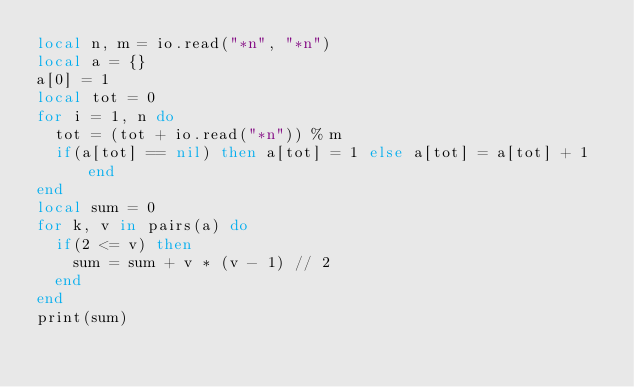Convert code to text. <code><loc_0><loc_0><loc_500><loc_500><_Lua_>local n, m = io.read("*n", "*n")
local a = {}
a[0] = 1
local tot = 0
for i = 1, n do
  tot = (tot + io.read("*n")) % m
  if(a[tot] == nil) then a[tot] = 1 else a[tot] = a[tot] + 1 end
end
local sum = 0
for k, v in pairs(a) do
  if(2 <= v) then
    sum = sum + v * (v - 1) // 2
  end
end
print(sum)
</code> 